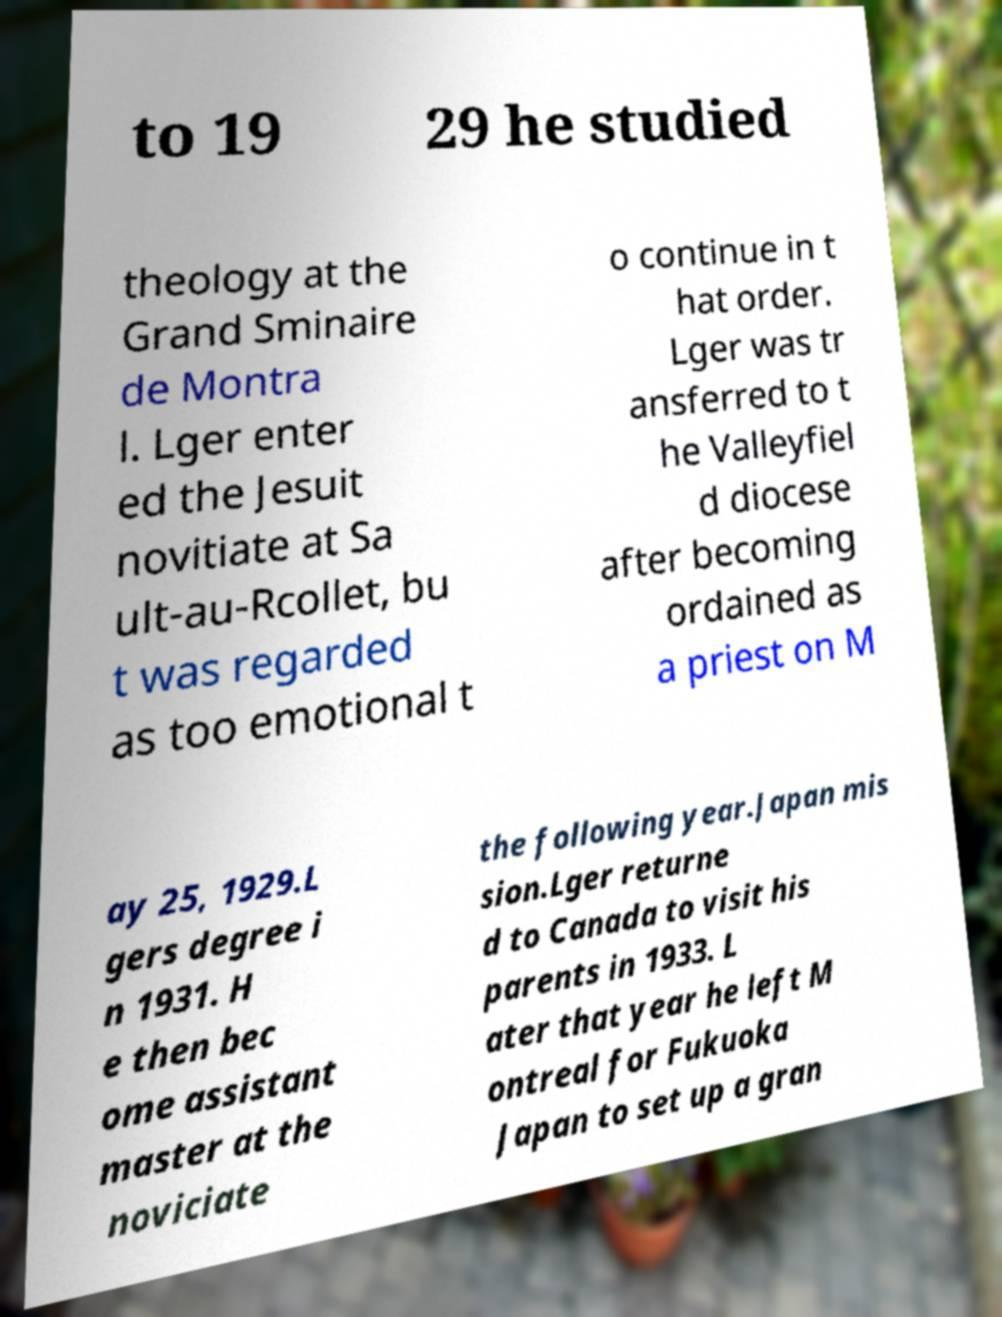Please identify and transcribe the text found in this image. to 19 29 he studied theology at the Grand Sminaire de Montra l. Lger enter ed the Jesuit novitiate at Sa ult-au-Rcollet, bu t was regarded as too emotional t o continue in t hat order. Lger was tr ansferred to t he Valleyfiel d diocese after becoming ordained as a priest on M ay 25, 1929.L gers degree i n 1931. H e then bec ome assistant master at the noviciate the following year.Japan mis sion.Lger returne d to Canada to visit his parents in 1933. L ater that year he left M ontreal for Fukuoka Japan to set up a gran 